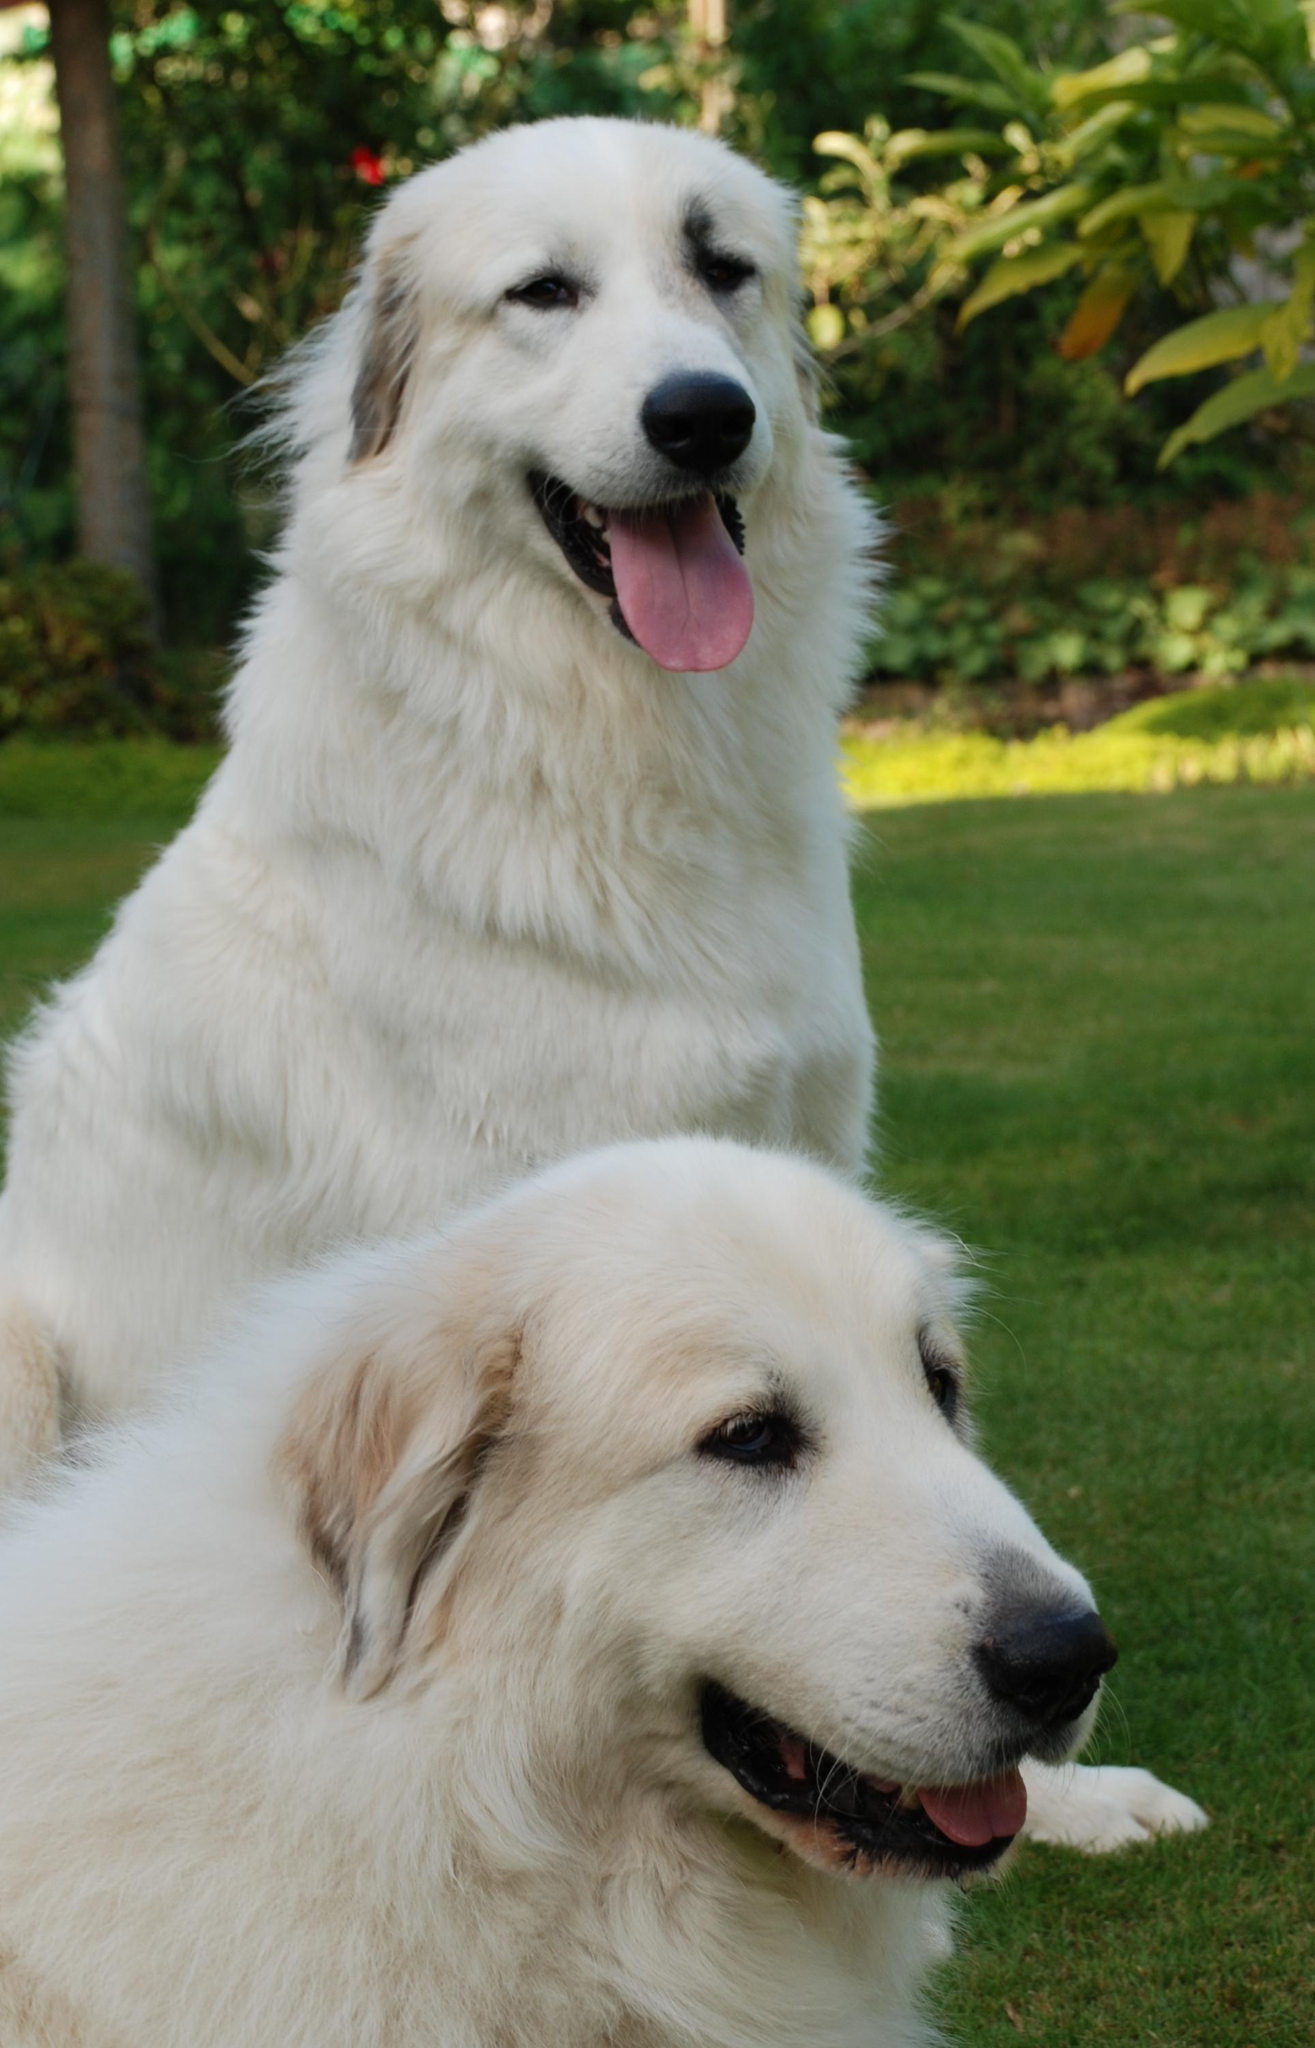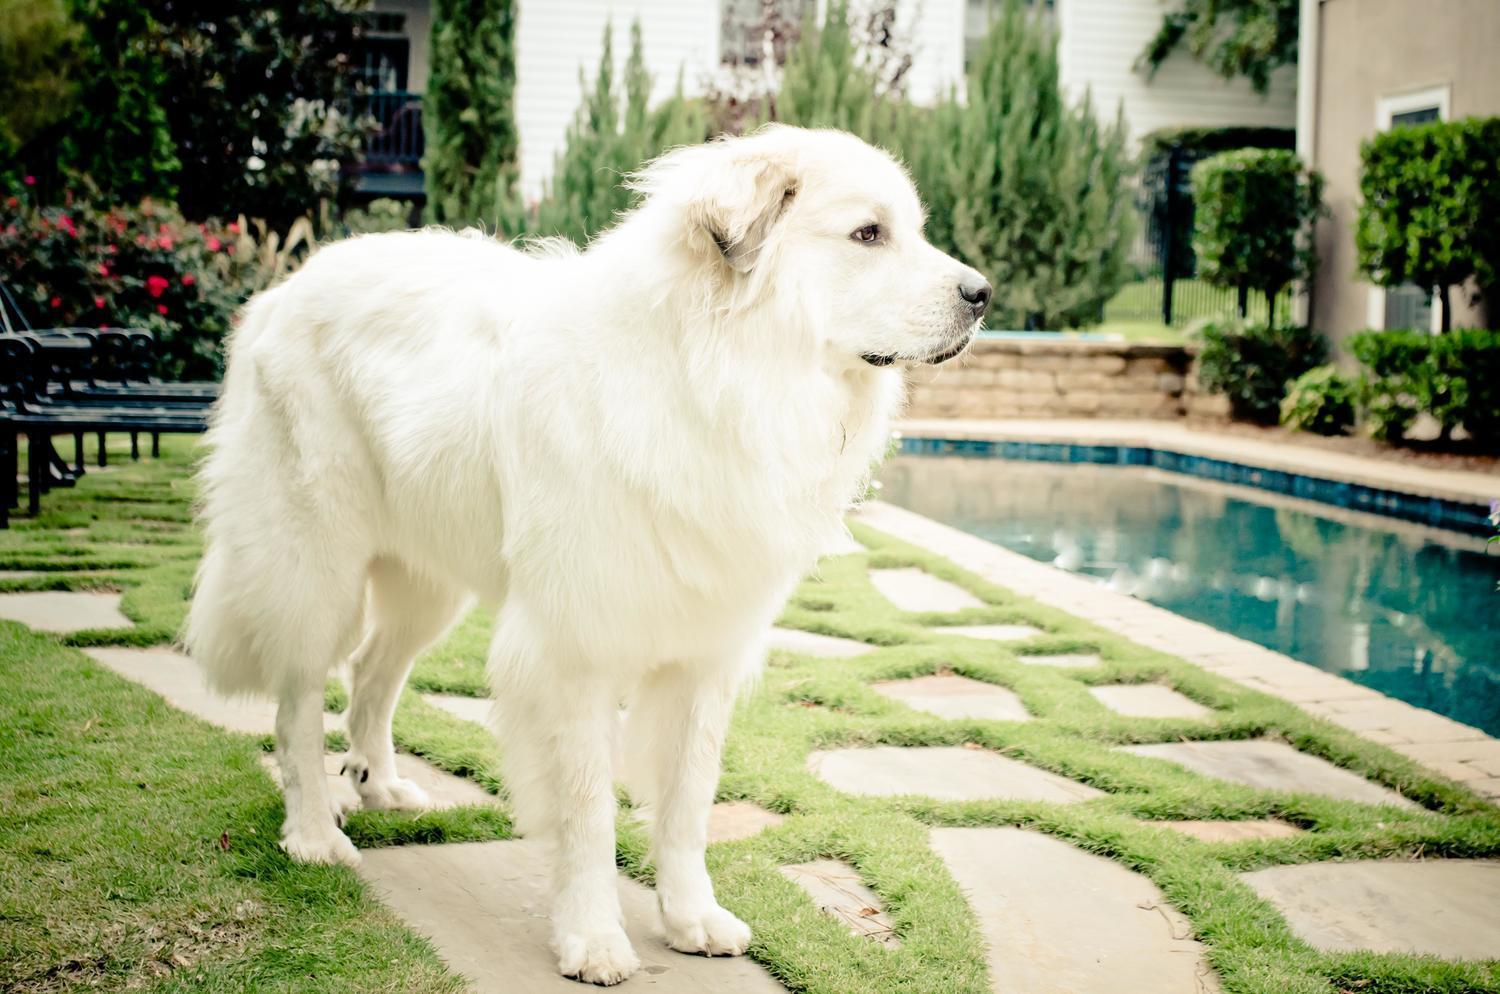The first image is the image on the left, the second image is the image on the right. Analyze the images presented: Is the assertion "One image only shows the face and chest of a dog facing left." valid? Answer yes or no. No. The first image is the image on the left, the second image is the image on the right. Examine the images to the left and right. Is the description "There is one dog facing right in the right image." accurate? Answer yes or no. Yes. 